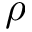Convert formula to latex. <formula><loc_0><loc_0><loc_500><loc_500>\rho</formula> 